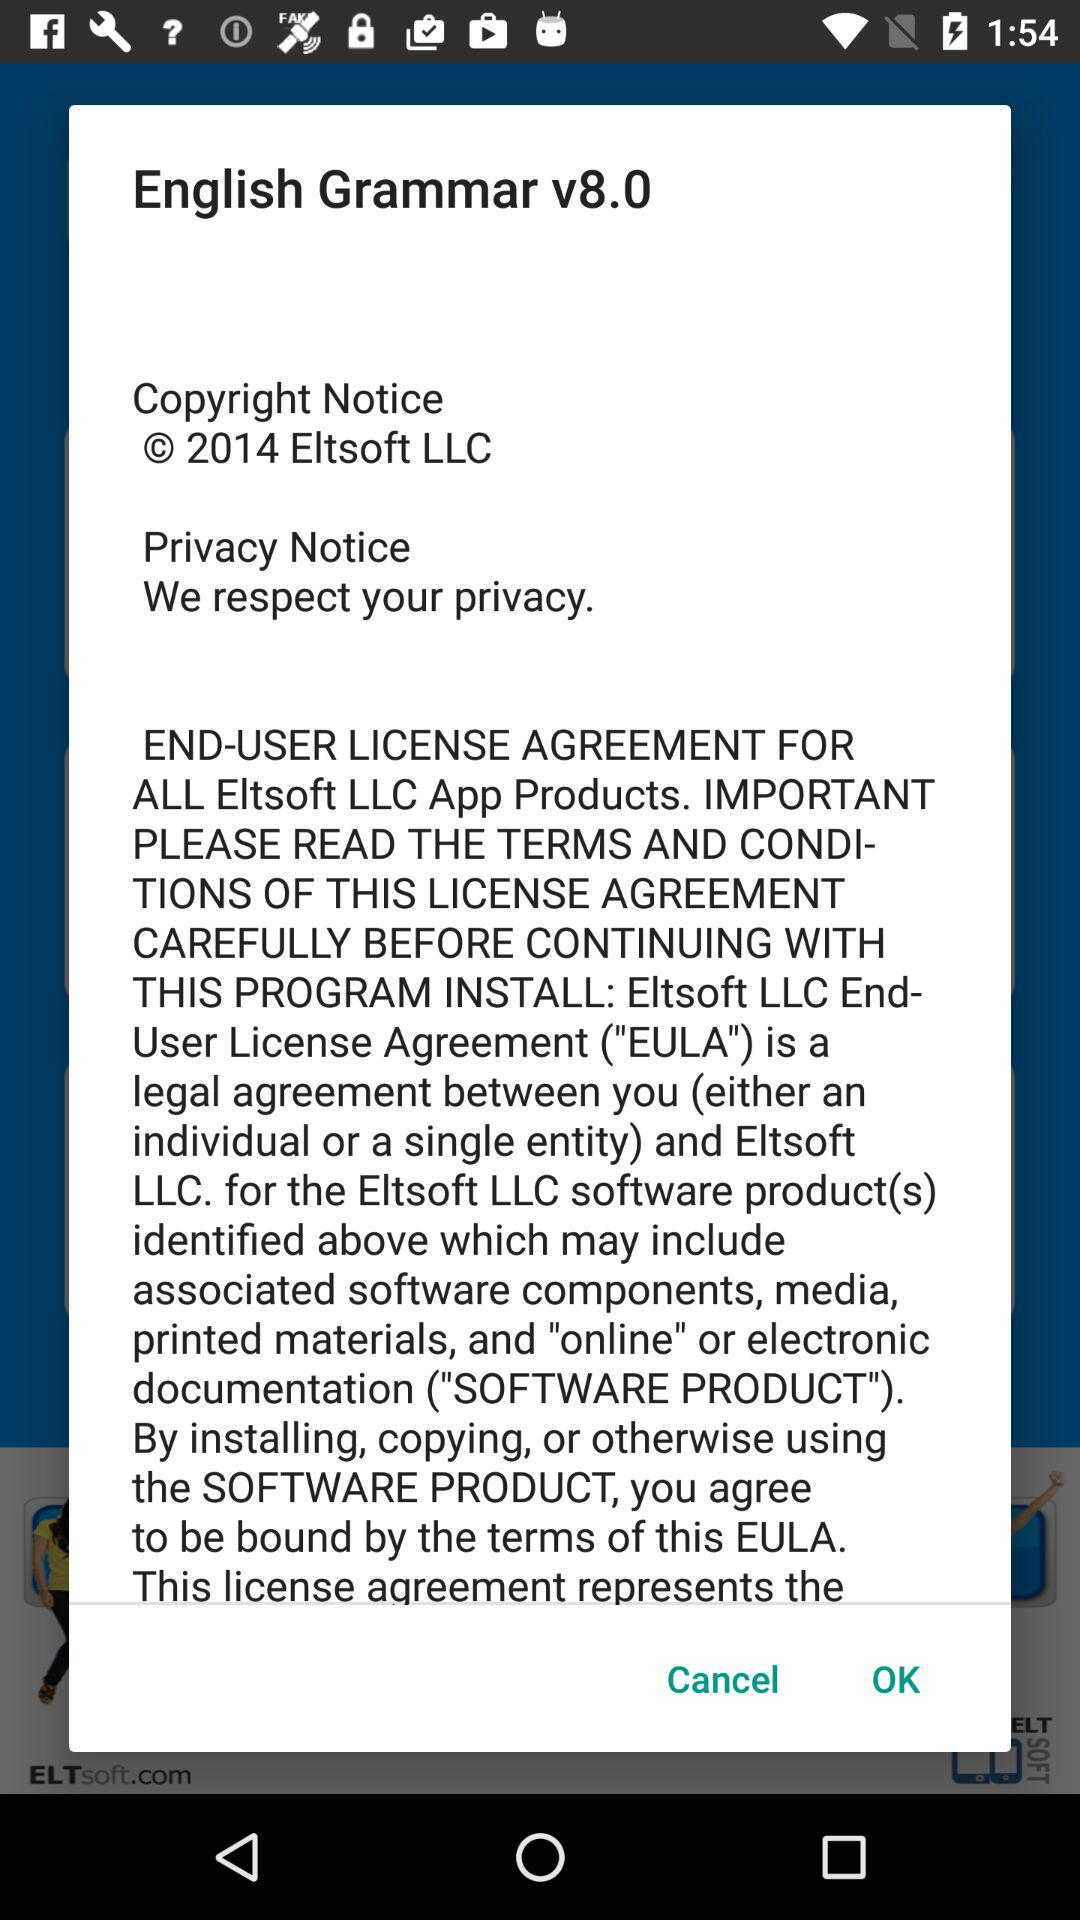What is the full form of EULA? The full form of EULA is End-User License Agreement. 